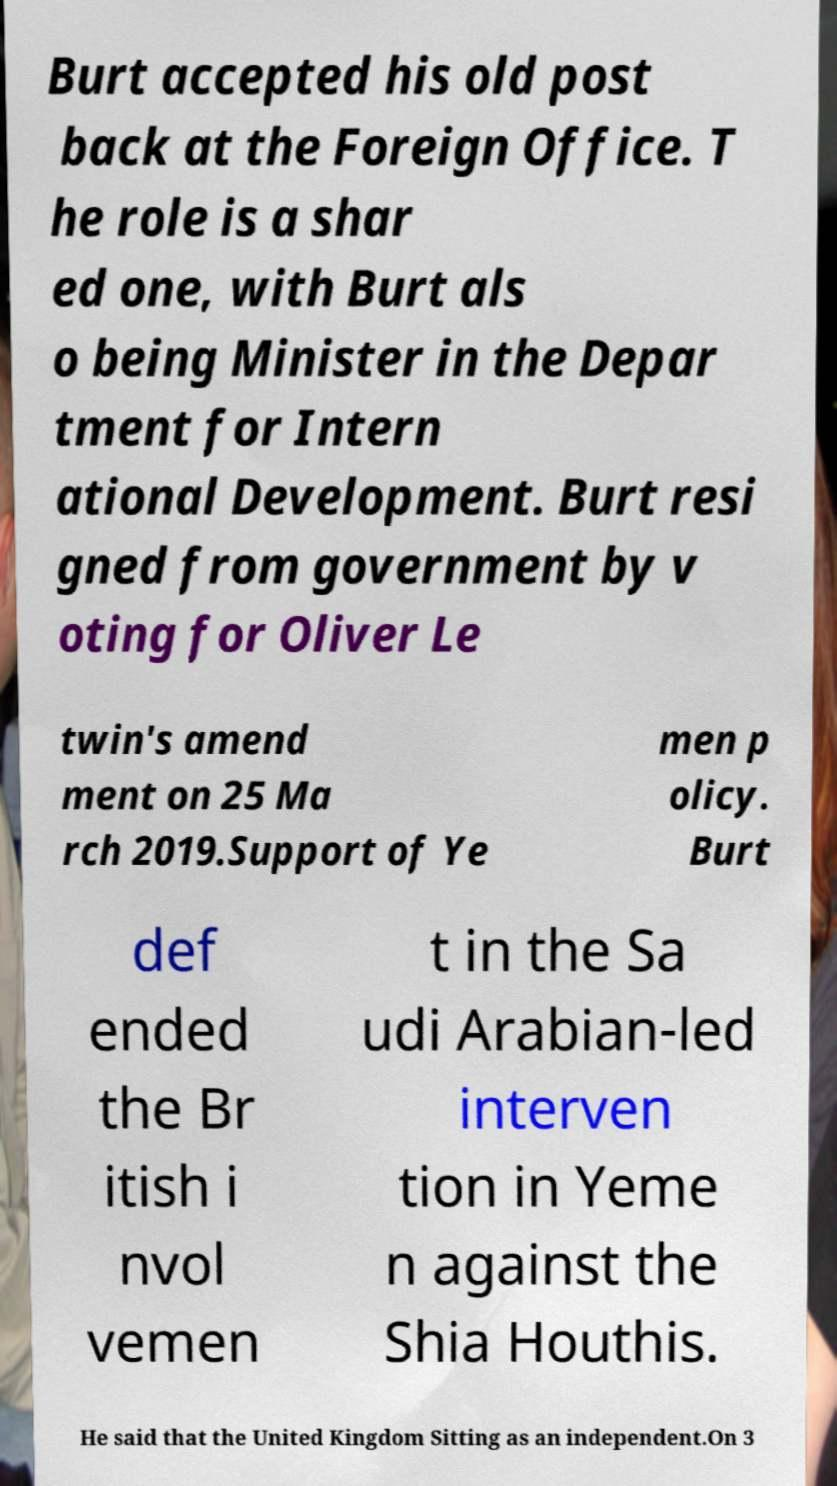Can you accurately transcribe the text from the provided image for me? Burt accepted his old post back at the Foreign Office. T he role is a shar ed one, with Burt als o being Minister in the Depar tment for Intern ational Development. Burt resi gned from government by v oting for Oliver Le twin's amend ment on 25 Ma rch 2019.Support of Ye men p olicy. Burt def ended the Br itish i nvol vemen t in the Sa udi Arabian-led interven tion in Yeme n against the Shia Houthis. He said that the United Kingdom Sitting as an independent.On 3 